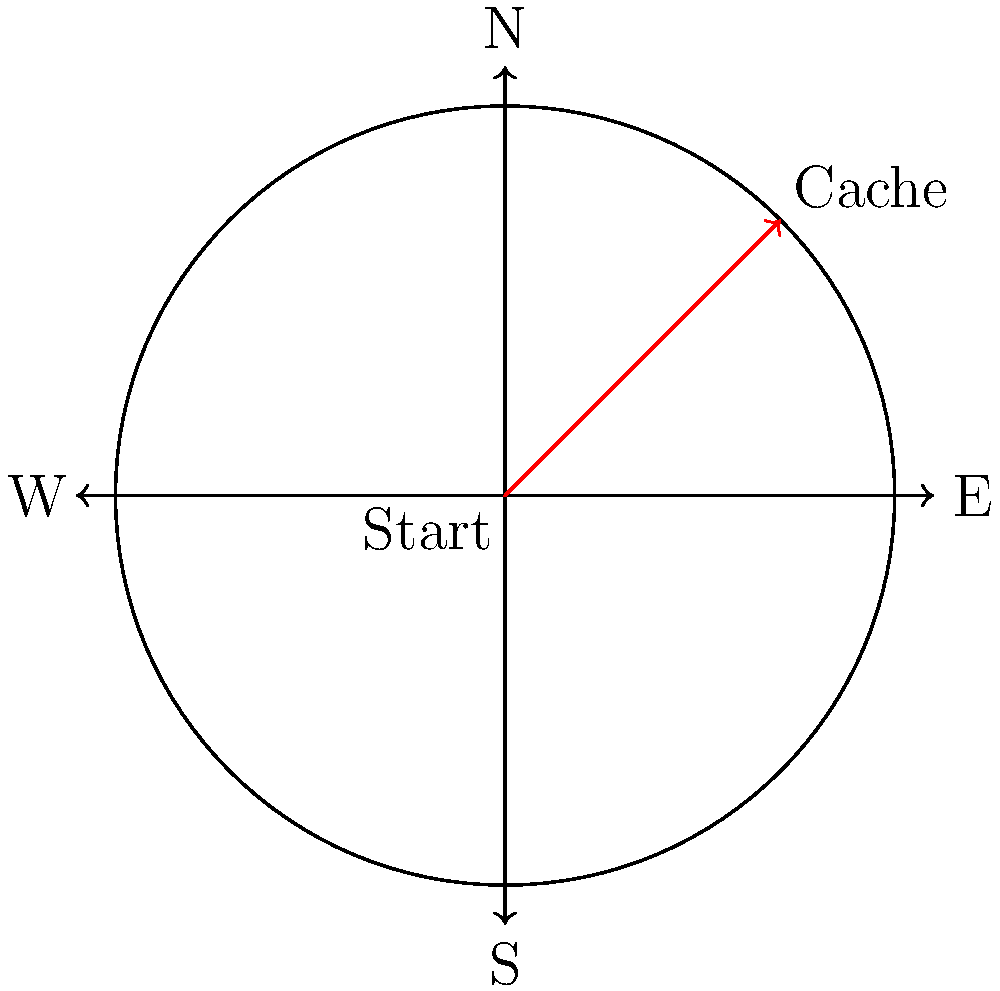As a new geocacher, you're given a compass and told that a cache is located at a bearing of 45° from your starting point. Based on the diagram, in which direction would you need to travel to find the cache? To answer this question, let's break it down step-by-step:

1. First, recall that compass directions are typically labeled as follows:
   - North (N) is at 0° or 360°
   - East (E) is at 90°
   - South (S) is at 180°
   - West (W) is at 270°

2. The question states that the cache is located at a bearing of 45°.

3. On a compass, 45° is exactly halfway between North (0°) and East (90°).

4. This direction is commonly referred to as Northeast (NE).

5. Looking at the diagram, we can see a red arrow pointing from the center (labeled "Start") towards the edge of the circle at the 45° angle.

6. The endpoint of this red arrow is labeled "Cache".

7. This confirms that the cache is indeed located in the Northeast direction from the starting point.

Therefore, to find the cache, you would need to travel in the Northeast (NE) direction from your starting point.
Answer: Northeast (NE) 